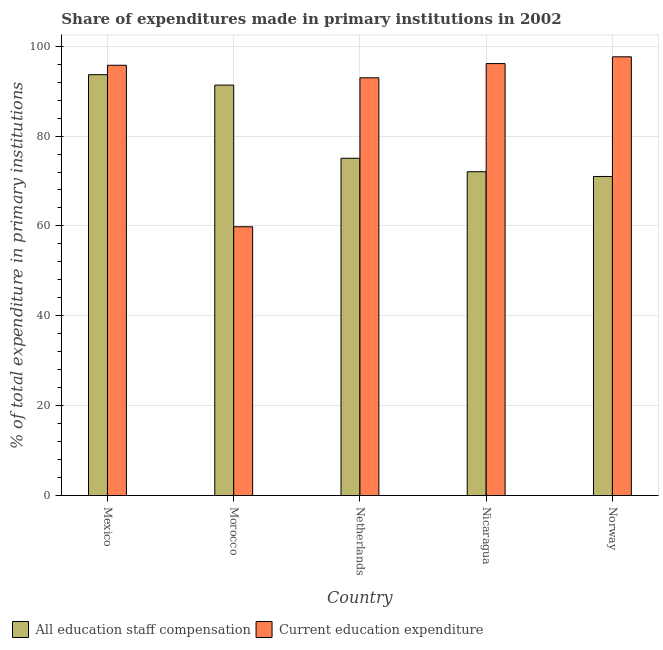How many different coloured bars are there?
Make the answer very short. 2. How many groups of bars are there?
Give a very brief answer. 5. Are the number of bars per tick equal to the number of legend labels?
Your response must be concise. Yes. Are the number of bars on each tick of the X-axis equal?
Make the answer very short. Yes. How many bars are there on the 3rd tick from the left?
Make the answer very short. 2. What is the label of the 5th group of bars from the left?
Keep it short and to the point. Norway. What is the expenditure in staff compensation in Mexico?
Make the answer very short. 93.66. Across all countries, what is the maximum expenditure in education?
Your answer should be very brief. 97.64. Across all countries, what is the minimum expenditure in staff compensation?
Ensure brevity in your answer.  71.01. In which country was the expenditure in staff compensation minimum?
Ensure brevity in your answer.  Norway. What is the total expenditure in education in the graph?
Your response must be concise. 442.31. What is the difference between the expenditure in staff compensation in Mexico and that in Norway?
Provide a succinct answer. 22.66. What is the difference between the expenditure in staff compensation in Netherlands and the expenditure in education in Nicaragua?
Offer a very short reply. -21.07. What is the average expenditure in education per country?
Give a very brief answer. 88.46. What is the difference between the expenditure in staff compensation and expenditure in education in Norway?
Offer a terse response. -26.63. In how many countries, is the expenditure in education greater than 24 %?
Offer a very short reply. 5. What is the ratio of the expenditure in education in Mexico to that in Morocco?
Your answer should be compact. 1.6. What is the difference between the highest and the second highest expenditure in education?
Offer a terse response. 1.51. What is the difference between the highest and the lowest expenditure in education?
Make the answer very short. 37.82. In how many countries, is the expenditure in staff compensation greater than the average expenditure in staff compensation taken over all countries?
Your answer should be compact. 2. What does the 2nd bar from the left in Nicaragua represents?
Make the answer very short. Current education expenditure. What does the 1st bar from the right in Nicaragua represents?
Offer a very short reply. Current education expenditure. What is the difference between two consecutive major ticks on the Y-axis?
Offer a terse response. 20. Does the graph contain grids?
Provide a succinct answer. Yes. How many legend labels are there?
Give a very brief answer. 2. What is the title of the graph?
Offer a terse response. Share of expenditures made in primary institutions in 2002. Does "Export" appear as one of the legend labels in the graph?
Keep it short and to the point. No. What is the label or title of the Y-axis?
Your answer should be compact. % of total expenditure in primary institutions. What is the % of total expenditure in primary institutions of All education staff compensation in Mexico?
Give a very brief answer. 93.66. What is the % of total expenditure in primary institutions in Current education expenditure in Mexico?
Offer a terse response. 95.76. What is the % of total expenditure in primary institutions in All education staff compensation in Morocco?
Your response must be concise. 91.35. What is the % of total expenditure in primary institutions of Current education expenditure in Morocco?
Provide a succinct answer. 59.82. What is the % of total expenditure in primary institutions in All education staff compensation in Netherlands?
Make the answer very short. 75.06. What is the % of total expenditure in primary institutions in Current education expenditure in Netherlands?
Your answer should be compact. 92.96. What is the % of total expenditure in primary institutions in All education staff compensation in Nicaragua?
Your answer should be very brief. 72.06. What is the % of total expenditure in primary institutions in Current education expenditure in Nicaragua?
Offer a terse response. 96.13. What is the % of total expenditure in primary institutions of All education staff compensation in Norway?
Ensure brevity in your answer.  71.01. What is the % of total expenditure in primary institutions of Current education expenditure in Norway?
Your answer should be compact. 97.64. Across all countries, what is the maximum % of total expenditure in primary institutions in All education staff compensation?
Provide a succinct answer. 93.66. Across all countries, what is the maximum % of total expenditure in primary institutions of Current education expenditure?
Your response must be concise. 97.64. Across all countries, what is the minimum % of total expenditure in primary institutions in All education staff compensation?
Your response must be concise. 71.01. Across all countries, what is the minimum % of total expenditure in primary institutions in Current education expenditure?
Your response must be concise. 59.82. What is the total % of total expenditure in primary institutions of All education staff compensation in the graph?
Give a very brief answer. 403.14. What is the total % of total expenditure in primary institutions of Current education expenditure in the graph?
Offer a very short reply. 442.31. What is the difference between the % of total expenditure in primary institutions in All education staff compensation in Mexico and that in Morocco?
Keep it short and to the point. 2.32. What is the difference between the % of total expenditure in primary institutions in Current education expenditure in Mexico and that in Morocco?
Your answer should be very brief. 35.94. What is the difference between the % of total expenditure in primary institutions of All education staff compensation in Mexico and that in Netherlands?
Offer a very short reply. 18.6. What is the difference between the % of total expenditure in primary institutions in Current education expenditure in Mexico and that in Netherlands?
Your answer should be very brief. 2.79. What is the difference between the % of total expenditure in primary institutions of All education staff compensation in Mexico and that in Nicaragua?
Offer a terse response. 21.6. What is the difference between the % of total expenditure in primary institutions of Current education expenditure in Mexico and that in Nicaragua?
Your response must be concise. -0.37. What is the difference between the % of total expenditure in primary institutions in All education staff compensation in Mexico and that in Norway?
Make the answer very short. 22.66. What is the difference between the % of total expenditure in primary institutions of Current education expenditure in Mexico and that in Norway?
Your answer should be compact. -1.88. What is the difference between the % of total expenditure in primary institutions of All education staff compensation in Morocco and that in Netherlands?
Provide a succinct answer. 16.29. What is the difference between the % of total expenditure in primary institutions of Current education expenditure in Morocco and that in Netherlands?
Your answer should be compact. -33.15. What is the difference between the % of total expenditure in primary institutions in All education staff compensation in Morocco and that in Nicaragua?
Ensure brevity in your answer.  19.28. What is the difference between the % of total expenditure in primary institutions in Current education expenditure in Morocco and that in Nicaragua?
Offer a terse response. -36.31. What is the difference between the % of total expenditure in primary institutions of All education staff compensation in Morocco and that in Norway?
Your answer should be very brief. 20.34. What is the difference between the % of total expenditure in primary institutions in Current education expenditure in Morocco and that in Norway?
Ensure brevity in your answer.  -37.82. What is the difference between the % of total expenditure in primary institutions in All education staff compensation in Netherlands and that in Nicaragua?
Give a very brief answer. 3. What is the difference between the % of total expenditure in primary institutions in Current education expenditure in Netherlands and that in Nicaragua?
Make the answer very short. -3.17. What is the difference between the % of total expenditure in primary institutions in All education staff compensation in Netherlands and that in Norway?
Give a very brief answer. 4.05. What is the difference between the % of total expenditure in primary institutions in Current education expenditure in Netherlands and that in Norway?
Your answer should be compact. -4.67. What is the difference between the % of total expenditure in primary institutions in All education staff compensation in Nicaragua and that in Norway?
Give a very brief answer. 1.05. What is the difference between the % of total expenditure in primary institutions in Current education expenditure in Nicaragua and that in Norway?
Make the answer very short. -1.51. What is the difference between the % of total expenditure in primary institutions in All education staff compensation in Mexico and the % of total expenditure in primary institutions in Current education expenditure in Morocco?
Give a very brief answer. 33.84. What is the difference between the % of total expenditure in primary institutions in All education staff compensation in Mexico and the % of total expenditure in primary institutions in Current education expenditure in Netherlands?
Make the answer very short. 0.7. What is the difference between the % of total expenditure in primary institutions in All education staff compensation in Mexico and the % of total expenditure in primary institutions in Current education expenditure in Nicaragua?
Provide a short and direct response. -2.47. What is the difference between the % of total expenditure in primary institutions of All education staff compensation in Mexico and the % of total expenditure in primary institutions of Current education expenditure in Norway?
Give a very brief answer. -3.97. What is the difference between the % of total expenditure in primary institutions in All education staff compensation in Morocco and the % of total expenditure in primary institutions in Current education expenditure in Netherlands?
Provide a succinct answer. -1.62. What is the difference between the % of total expenditure in primary institutions of All education staff compensation in Morocco and the % of total expenditure in primary institutions of Current education expenditure in Nicaragua?
Your answer should be very brief. -4.78. What is the difference between the % of total expenditure in primary institutions of All education staff compensation in Morocco and the % of total expenditure in primary institutions of Current education expenditure in Norway?
Ensure brevity in your answer.  -6.29. What is the difference between the % of total expenditure in primary institutions in All education staff compensation in Netherlands and the % of total expenditure in primary institutions in Current education expenditure in Nicaragua?
Your answer should be compact. -21.07. What is the difference between the % of total expenditure in primary institutions of All education staff compensation in Netherlands and the % of total expenditure in primary institutions of Current education expenditure in Norway?
Give a very brief answer. -22.58. What is the difference between the % of total expenditure in primary institutions of All education staff compensation in Nicaragua and the % of total expenditure in primary institutions of Current education expenditure in Norway?
Provide a succinct answer. -25.58. What is the average % of total expenditure in primary institutions of All education staff compensation per country?
Your answer should be compact. 80.63. What is the average % of total expenditure in primary institutions of Current education expenditure per country?
Offer a very short reply. 88.46. What is the difference between the % of total expenditure in primary institutions in All education staff compensation and % of total expenditure in primary institutions in Current education expenditure in Mexico?
Provide a succinct answer. -2.1. What is the difference between the % of total expenditure in primary institutions in All education staff compensation and % of total expenditure in primary institutions in Current education expenditure in Morocco?
Ensure brevity in your answer.  31.53. What is the difference between the % of total expenditure in primary institutions of All education staff compensation and % of total expenditure in primary institutions of Current education expenditure in Netherlands?
Give a very brief answer. -17.9. What is the difference between the % of total expenditure in primary institutions in All education staff compensation and % of total expenditure in primary institutions in Current education expenditure in Nicaragua?
Your answer should be very brief. -24.07. What is the difference between the % of total expenditure in primary institutions of All education staff compensation and % of total expenditure in primary institutions of Current education expenditure in Norway?
Provide a succinct answer. -26.63. What is the ratio of the % of total expenditure in primary institutions in All education staff compensation in Mexico to that in Morocco?
Offer a very short reply. 1.03. What is the ratio of the % of total expenditure in primary institutions of Current education expenditure in Mexico to that in Morocco?
Your answer should be very brief. 1.6. What is the ratio of the % of total expenditure in primary institutions in All education staff compensation in Mexico to that in Netherlands?
Your answer should be compact. 1.25. What is the ratio of the % of total expenditure in primary institutions in Current education expenditure in Mexico to that in Netherlands?
Give a very brief answer. 1.03. What is the ratio of the % of total expenditure in primary institutions of All education staff compensation in Mexico to that in Nicaragua?
Provide a succinct answer. 1.3. What is the ratio of the % of total expenditure in primary institutions in Current education expenditure in Mexico to that in Nicaragua?
Your answer should be very brief. 1. What is the ratio of the % of total expenditure in primary institutions in All education staff compensation in Mexico to that in Norway?
Offer a very short reply. 1.32. What is the ratio of the % of total expenditure in primary institutions of Current education expenditure in Mexico to that in Norway?
Offer a terse response. 0.98. What is the ratio of the % of total expenditure in primary institutions in All education staff compensation in Morocco to that in Netherlands?
Offer a very short reply. 1.22. What is the ratio of the % of total expenditure in primary institutions of Current education expenditure in Morocco to that in Netherlands?
Your answer should be very brief. 0.64. What is the ratio of the % of total expenditure in primary institutions in All education staff compensation in Morocco to that in Nicaragua?
Provide a succinct answer. 1.27. What is the ratio of the % of total expenditure in primary institutions in Current education expenditure in Morocco to that in Nicaragua?
Make the answer very short. 0.62. What is the ratio of the % of total expenditure in primary institutions of All education staff compensation in Morocco to that in Norway?
Your answer should be compact. 1.29. What is the ratio of the % of total expenditure in primary institutions in Current education expenditure in Morocco to that in Norway?
Provide a succinct answer. 0.61. What is the ratio of the % of total expenditure in primary institutions in All education staff compensation in Netherlands to that in Nicaragua?
Offer a very short reply. 1.04. What is the ratio of the % of total expenditure in primary institutions of Current education expenditure in Netherlands to that in Nicaragua?
Give a very brief answer. 0.97. What is the ratio of the % of total expenditure in primary institutions of All education staff compensation in Netherlands to that in Norway?
Make the answer very short. 1.06. What is the ratio of the % of total expenditure in primary institutions of Current education expenditure in Netherlands to that in Norway?
Your response must be concise. 0.95. What is the ratio of the % of total expenditure in primary institutions in All education staff compensation in Nicaragua to that in Norway?
Give a very brief answer. 1.01. What is the ratio of the % of total expenditure in primary institutions of Current education expenditure in Nicaragua to that in Norway?
Ensure brevity in your answer.  0.98. What is the difference between the highest and the second highest % of total expenditure in primary institutions of All education staff compensation?
Offer a terse response. 2.32. What is the difference between the highest and the second highest % of total expenditure in primary institutions of Current education expenditure?
Keep it short and to the point. 1.51. What is the difference between the highest and the lowest % of total expenditure in primary institutions of All education staff compensation?
Ensure brevity in your answer.  22.66. What is the difference between the highest and the lowest % of total expenditure in primary institutions of Current education expenditure?
Offer a terse response. 37.82. 